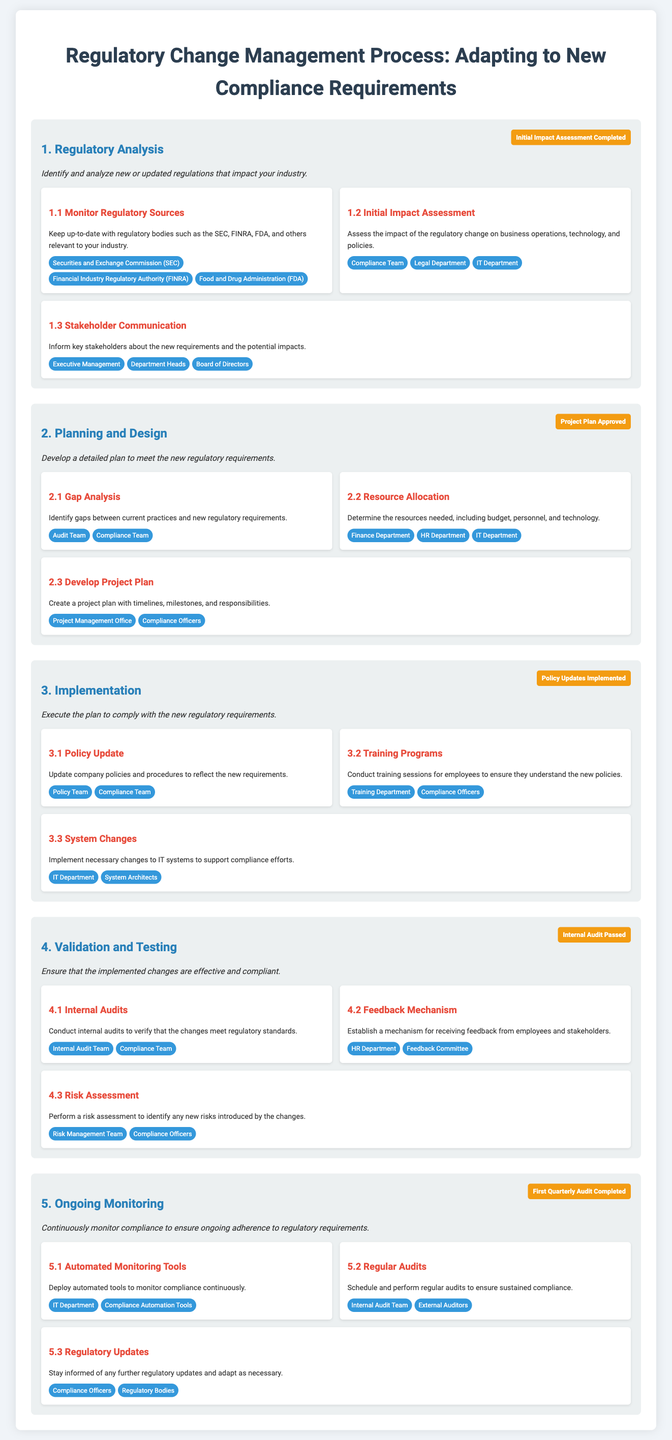What is the first step in the regulatory change management process? The first step is outlined in the section titled "1. Regulatory Analysis."
Answer: Regulatory Analysis Which entity is involved in monitoring regulatory sources? The document lists specific entities responsible for this step, such as the SEC.
Answer: Securities and Exchange Commission (SEC) What milestone is reached after the initial impact assessment? The infographic indicates that the milestone for this step is "Initial Impact Assessment Completed."
Answer: Initial Impact Assessment Completed How many steps are there in the implementation phase? The implementation phase includes three specific steps as detailed in the infographic.
Answer: 3 What is the purpose of the feedback mechanism in the validation and testing phase? The feedback mechanism is intended to receive feedback from employees and stakeholders.
Answer: Receiving feedback Which department is responsible for conducting regular audits? The responsibility for regular audits is mentioned for both internal and external auditors.
Answer: Internal Audit Team What tool is deployed for ongoing monitoring? The document specifies that automated monitoring tools are utilized in the ongoing monitoring steps.
Answer: Automated Monitoring Tools What is the final milestone in the ongoing monitoring phase? The infographic indicates the completion of the first quarterly audit as the final milestone for this phase.
Answer: First Quarterly Audit Completed 